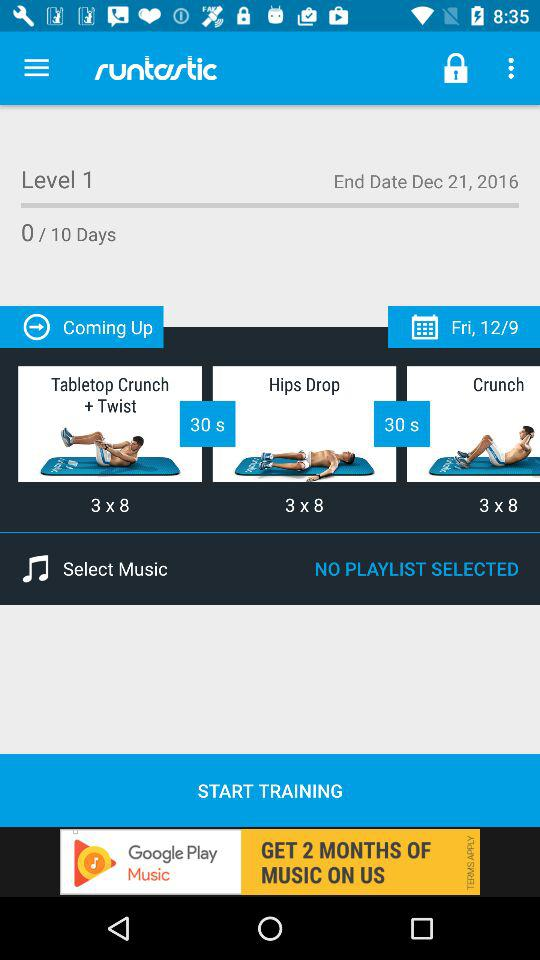What is the level of training? The level of training is 1. 